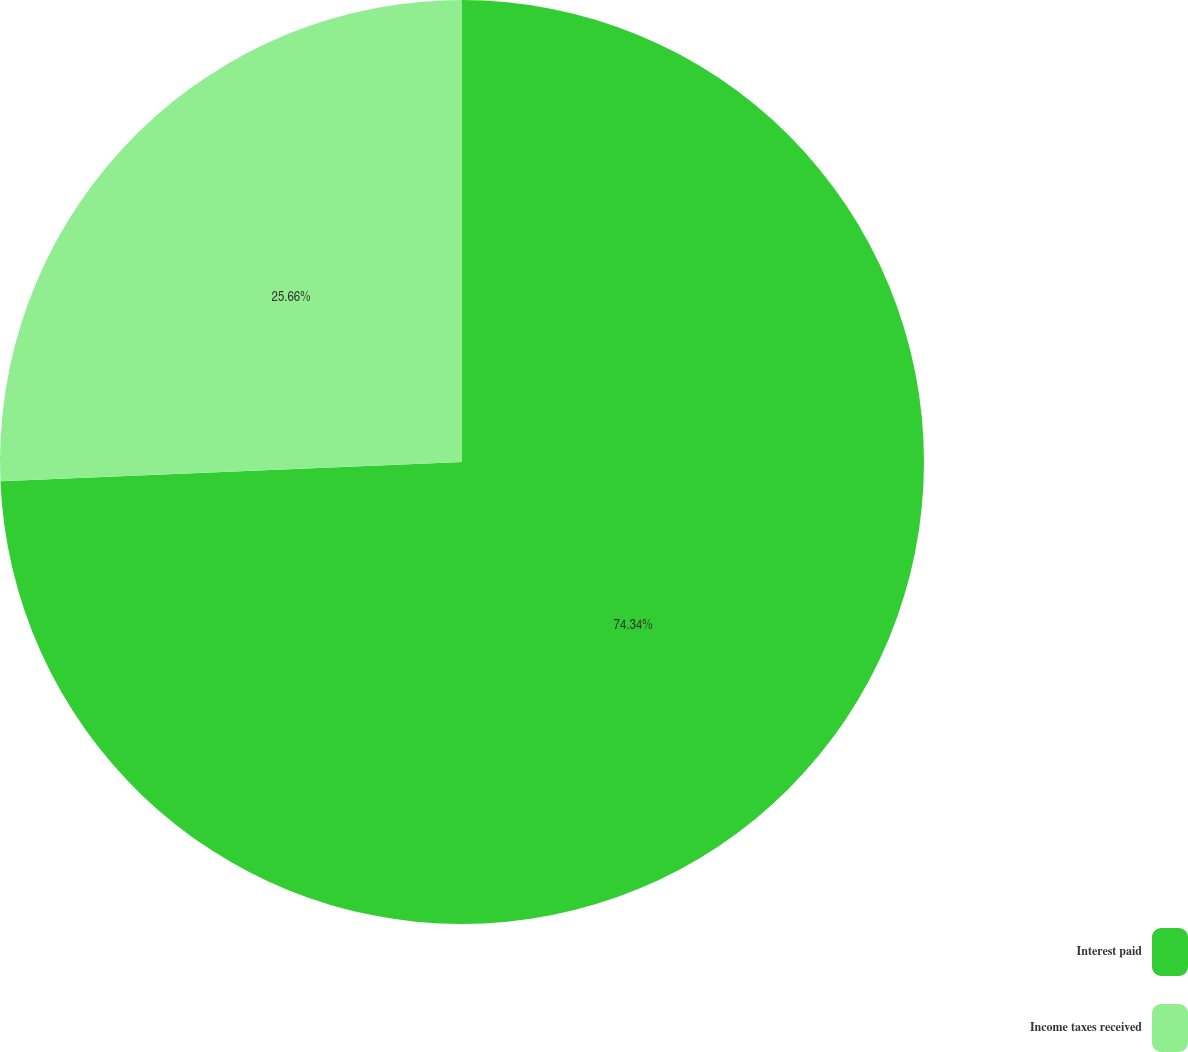<chart> <loc_0><loc_0><loc_500><loc_500><pie_chart><fcel>Interest paid<fcel>Income taxes received<nl><fcel>74.34%<fcel>25.66%<nl></chart> 